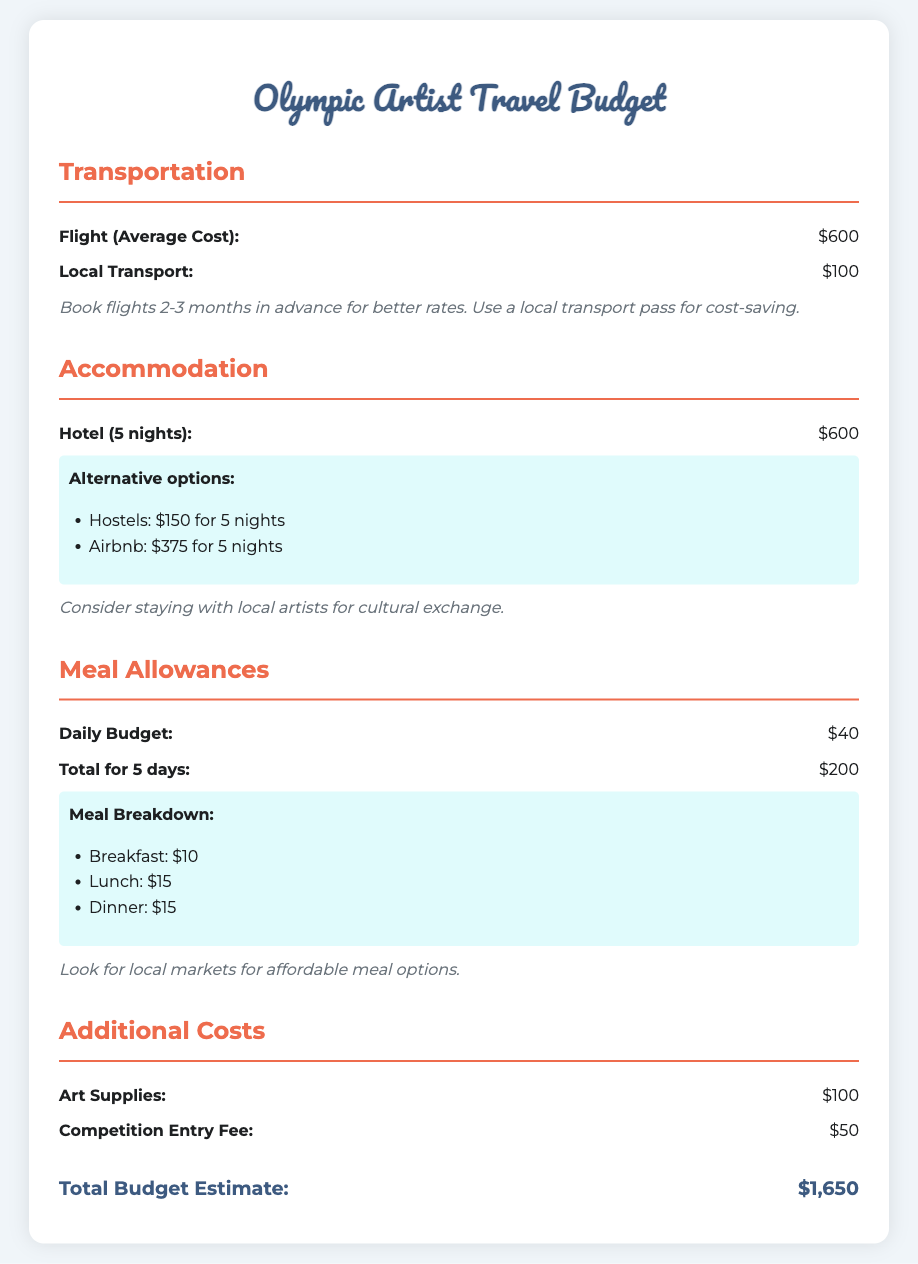What is the average cost of a flight? The document states the average cost of a flight is $600.
Answer: $600 How much will local transport cost? The document lists the cost of local transport as $100.
Answer: $100 What is the total estimated budget? The document summarizes the total budget estimate to be $1,650.
Answer: $1,650 What is the hotel cost for 5 nights? The document indicates that the hotel cost for 5 nights is $600.
Answer: $600 How much is the daily meal budget? The document specifies the daily meal budget as $40.
Answer: $40 What are the alternative accommodation options listed? The document lists hostels and Airbnb as alternative accommodation options.
Answer: Hostels and Airbnb What is the total meal allowance for 5 days? The document calculates the total meal allowance for 5 days as $200.
Answer: $200 What is the cost for art supplies? The document states the cost for art supplies is $100.
Answer: $100 What is the competition entry fee? The document shows that the competition entry fee is $50.
Answer: $50 